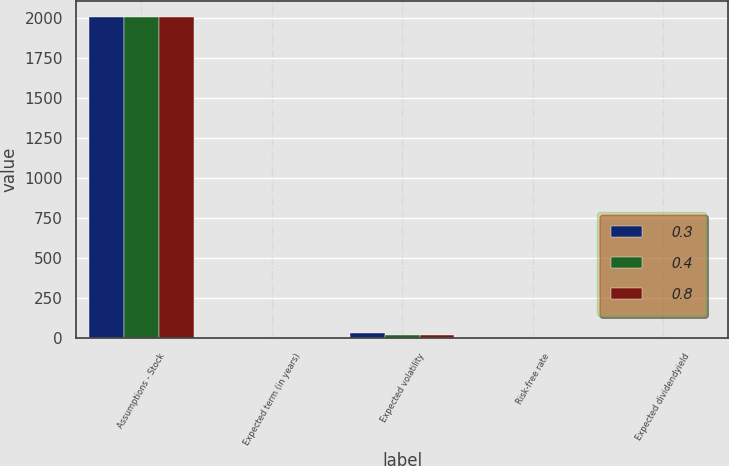Convert chart. <chart><loc_0><loc_0><loc_500><loc_500><stacked_bar_chart><ecel><fcel>Assumptions - Stock<fcel>Expected term (in years)<fcel>Expected volatility<fcel>Risk-free rate<fcel>Expected dividendyield<nl><fcel>0.3<fcel>2006<fcel>5.5<fcel>31.8<fcel>4.7<fcel>0.8<nl><fcel>0.4<fcel>2005<fcel>5.5<fcel>21.5<fcel>4.6<fcel>0.4<nl><fcel>0.8<fcel>2004<fcel>5.5<fcel>21.4<fcel>4.8<fcel>0.3<nl></chart> 